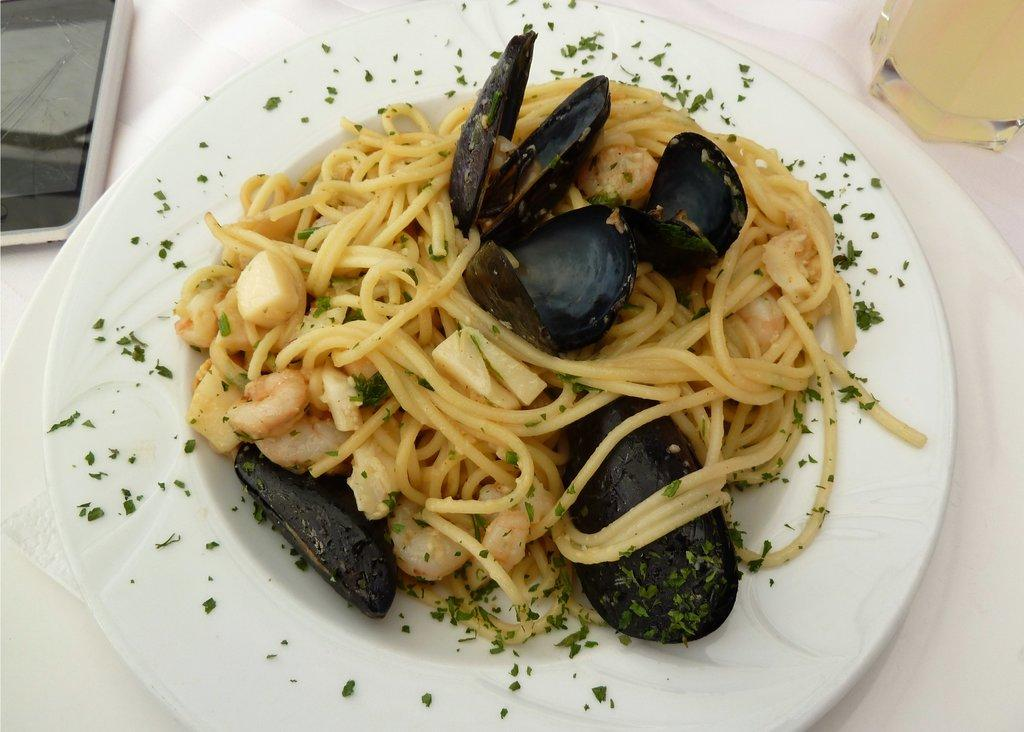What is the main piece of furniture in the image? There is a table in the image. What is covering the table? The table is covered with a white cloth. What is on the table besides the cloth? There is a plate on the table, and the plate contains food. What else can be seen on the table? There is a mobile and a glass on the table. How many boys are sitting at the table in the image? There is no boy present in the image. What type of goose is sitting on the plate with the food? There is no goose present in the image; the plate contains food, but no specific type of food is mentioned. 